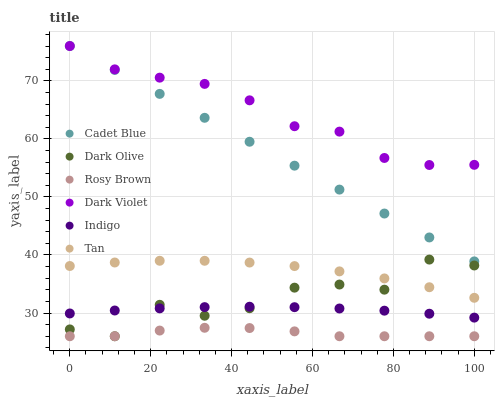Does Rosy Brown have the minimum area under the curve?
Answer yes or no. Yes. Does Dark Violet have the maximum area under the curve?
Answer yes or no. Yes. Does Indigo have the minimum area under the curve?
Answer yes or no. No. Does Indigo have the maximum area under the curve?
Answer yes or no. No. Is Cadet Blue the smoothest?
Answer yes or no. Yes. Is Dark Olive the roughest?
Answer yes or no. Yes. Is Indigo the smoothest?
Answer yes or no. No. Is Indigo the roughest?
Answer yes or no. No. Does Rosy Brown have the lowest value?
Answer yes or no. Yes. Does Indigo have the lowest value?
Answer yes or no. No. Does Cadet Blue have the highest value?
Answer yes or no. Yes. Does Indigo have the highest value?
Answer yes or no. No. Is Rosy Brown less than Dark Violet?
Answer yes or no. Yes. Is Indigo greater than Rosy Brown?
Answer yes or no. Yes. Does Dark Olive intersect Rosy Brown?
Answer yes or no. Yes. Is Dark Olive less than Rosy Brown?
Answer yes or no. No. Is Dark Olive greater than Rosy Brown?
Answer yes or no. No. Does Rosy Brown intersect Dark Violet?
Answer yes or no. No. 